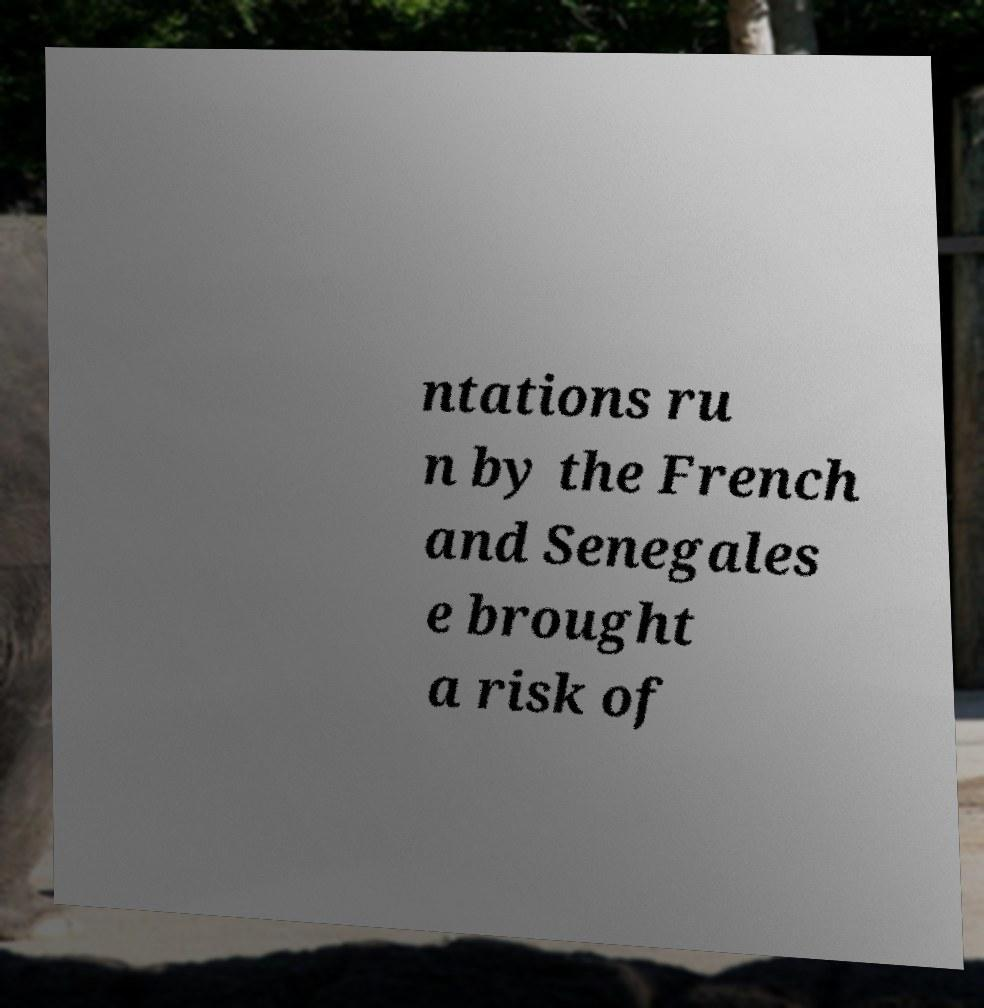Please read and relay the text visible in this image. What does it say? ntations ru n by the French and Senegales e brought a risk of 